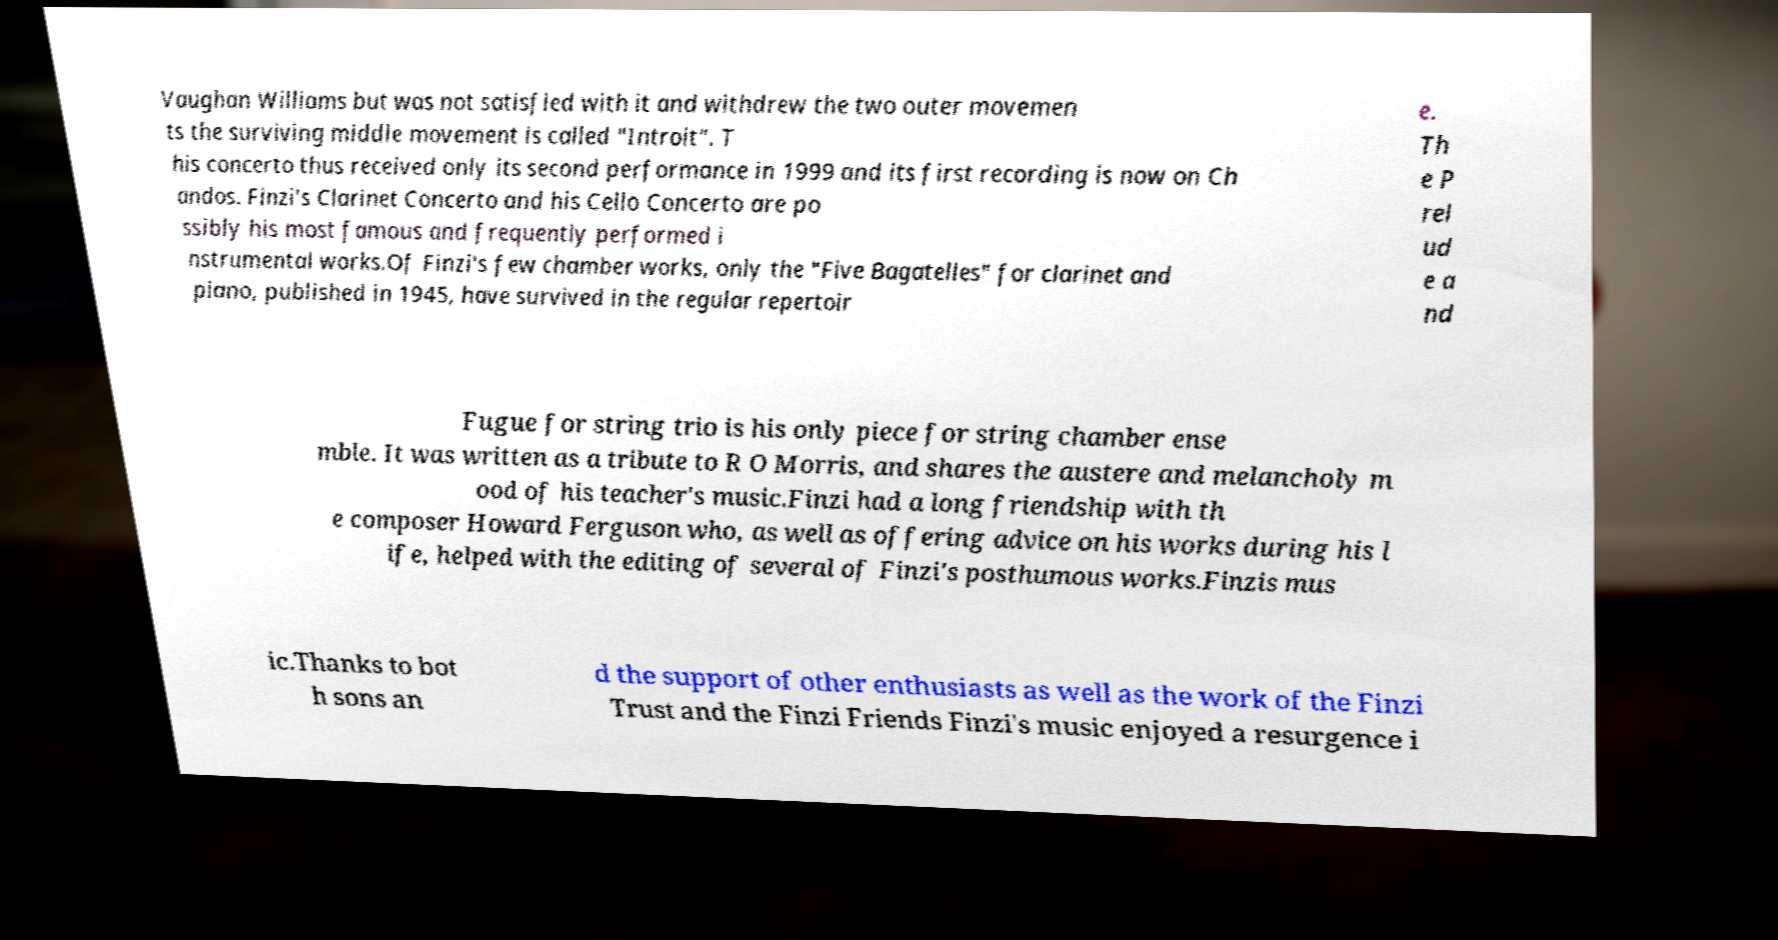There's text embedded in this image that I need extracted. Can you transcribe it verbatim? Vaughan Williams but was not satisfied with it and withdrew the two outer movemen ts the surviving middle movement is called "Introit". T his concerto thus received only its second performance in 1999 and its first recording is now on Ch andos. Finzi's Clarinet Concerto and his Cello Concerto are po ssibly his most famous and frequently performed i nstrumental works.Of Finzi's few chamber works, only the "Five Bagatelles" for clarinet and piano, published in 1945, have survived in the regular repertoir e. Th e P rel ud e a nd Fugue for string trio is his only piece for string chamber ense mble. It was written as a tribute to R O Morris, and shares the austere and melancholy m ood of his teacher's music.Finzi had a long friendship with th e composer Howard Ferguson who, as well as offering advice on his works during his l ife, helped with the editing of several of Finzi's posthumous works.Finzis mus ic.Thanks to bot h sons an d the support of other enthusiasts as well as the work of the Finzi Trust and the Finzi Friends Finzi's music enjoyed a resurgence i 